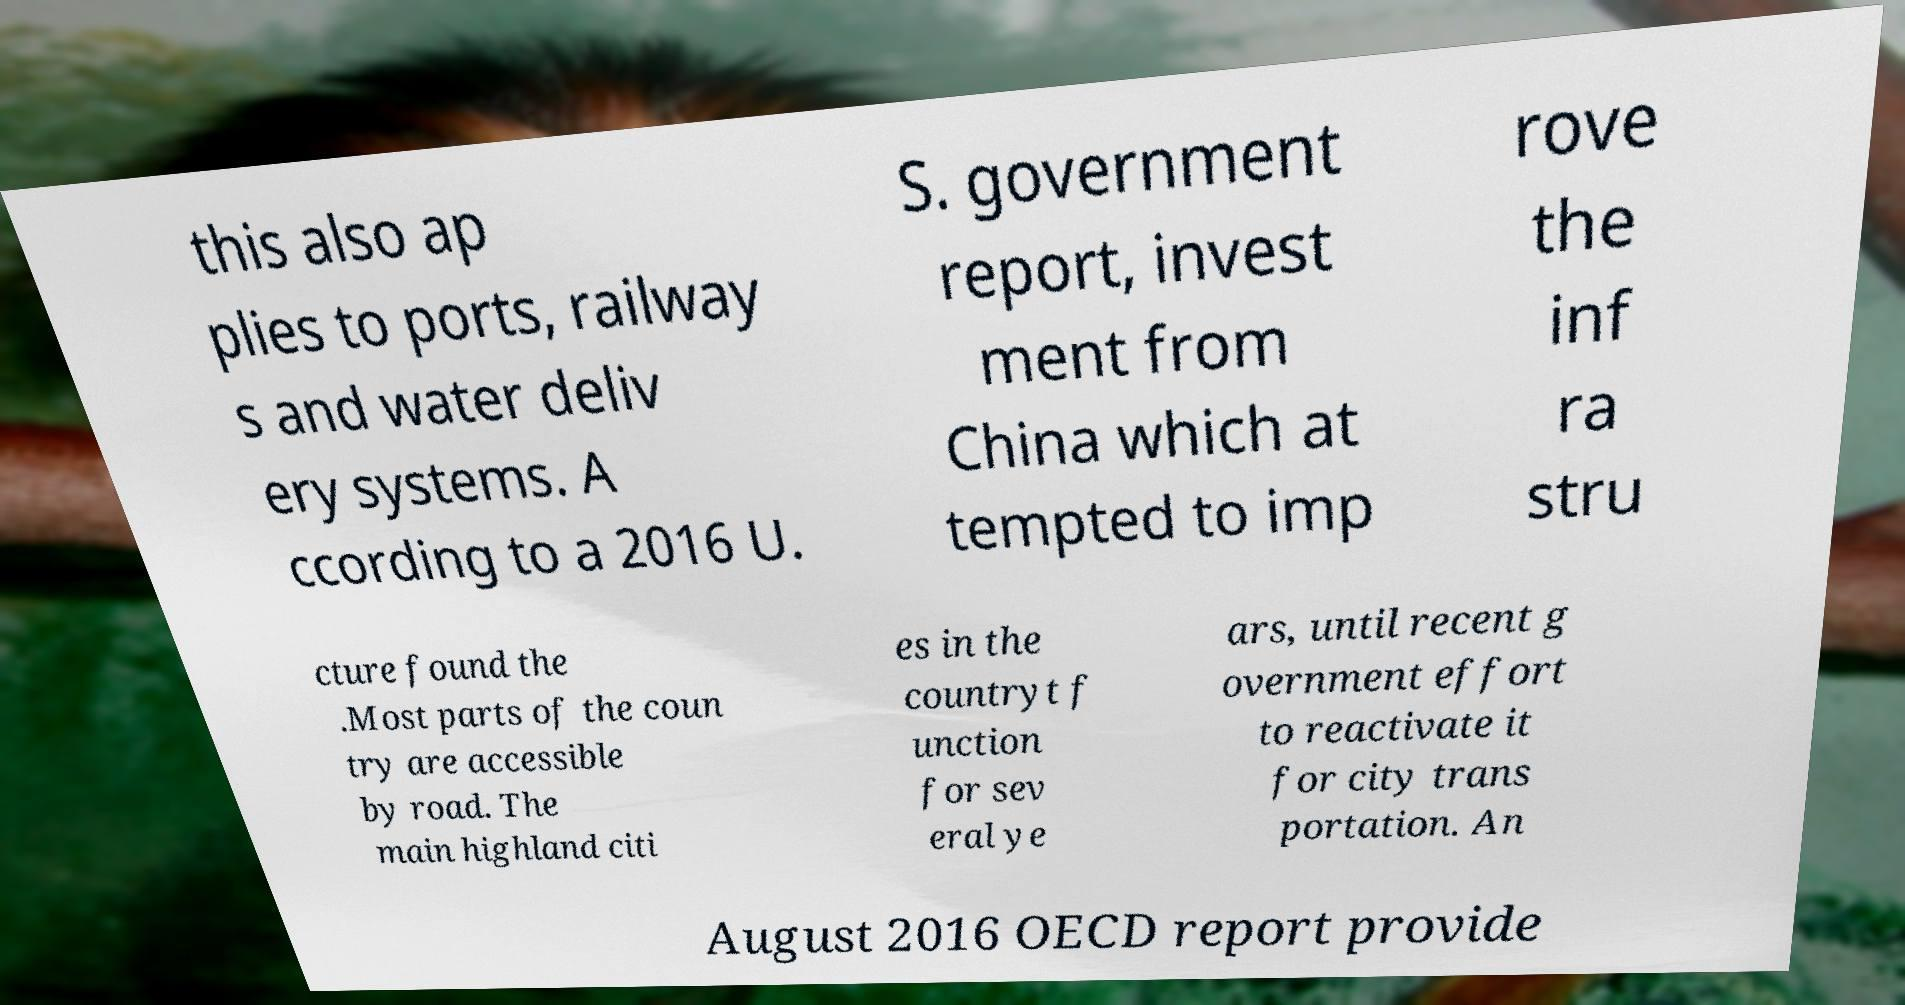What messages or text are displayed in this image? I need them in a readable, typed format. this also ap plies to ports, railway s and water deliv ery systems. A ccording to a 2016 U. S. government report, invest ment from China which at tempted to imp rove the inf ra stru cture found the .Most parts of the coun try are accessible by road. The main highland citi es in the countryt f unction for sev eral ye ars, until recent g overnment effort to reactivate it for city trans portation. An August 2016 OECD report provide 